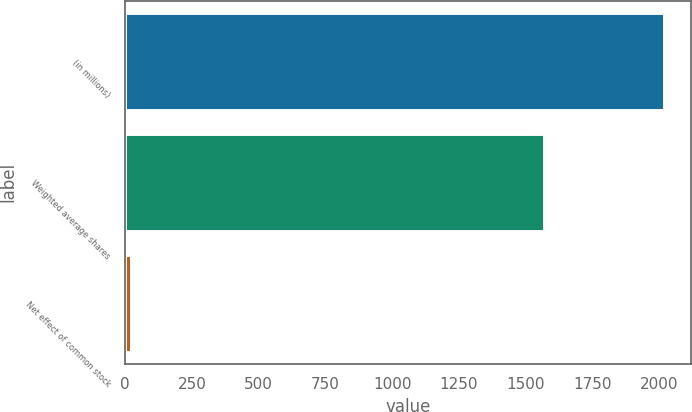Convert chart to OTSL. <chart><loc_0><loc_0><loc_500><loc_500><bar_chart><fcel>(in millions)<fcel>Weighted average shares<fcel>Net effect of common stock<nl><fcel>2017<fcel>1569.54<fcel>22.6<nl></chart> 